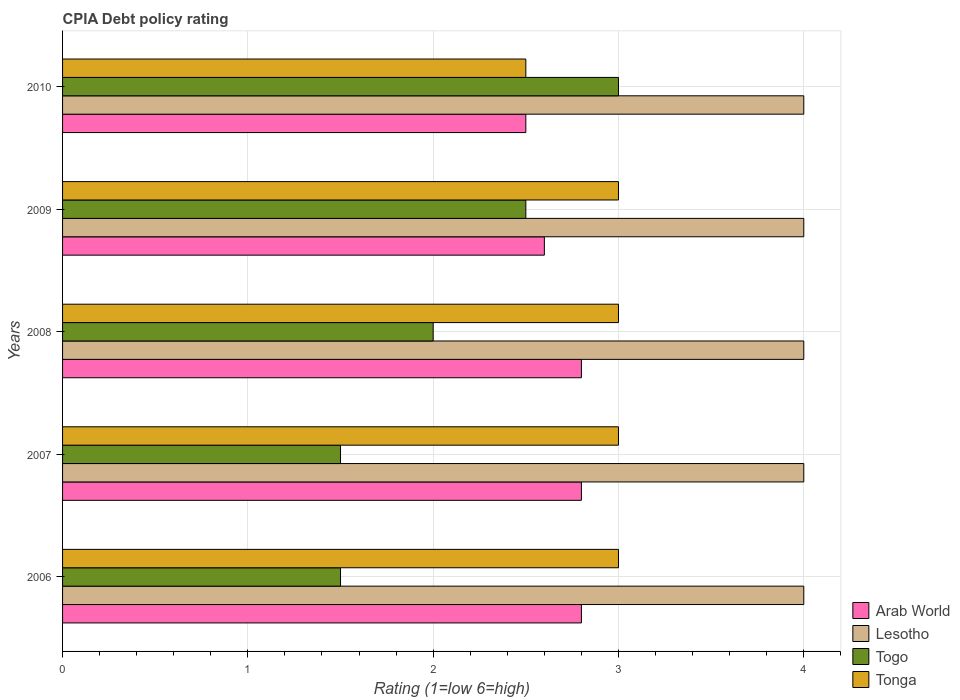How many groups of bars are there?
Offer a very short reply. 5. Are the number of bars per tick equal to the number of legend labels?
Your response must be concise. Yes. Are the number of bars on each tick of the Y-axis equal?
Provide a short and direct response. Yes. How many bars are there on the 5th tick from the top?
Provide a succinct answer. 4. How many bars are there on the 3rd tick from the bottom?
Your response must be concise. 4. What is the CPIA rating in Lesotho in 2009?
Your answer should be very brief. 4. Across all years, what is the maximum CPIA rating in Arab World?
Your answer should be very brief. 2.8. Across all years, what is the minimum CPIA rating in Tonga?
Ensure brevity in your answer.  2.5. What is the total CPIA rating in Tonga in the graph?
Your answer should be very brief. 14.5. What is the difference between the CPIA rating in Tonga in 2006 and the CPIA rating in Togo in 2010?
Make the answer very short. 0. In the year 2009, what is the difference between the CPIA rating in Lesotho and CPIA rating in Tonga?
Your answer should be very brief. 1. In how many years, is the CPIA rating in Lesotho greater than 2 ?
Offer a terse response. 5. What is the ratio of the CPIA rating in Togo in 2006 to that in 2010?
Your answer should be compact. 0.5. Is the CPIA rating in Lesotho in 2007 less than that in 2009?
Give a very brief answer. No. Is the difference between the CPIA rating in Lesotho in 2008 and 2010 greater than the difference between the CPIA rating in Tonga in 2008 and 2010?
Give a very brief answer. No. In how many years, is the CPIA rating in Lesotho greater than the average CPIA rating in Lesotho taken over all years?
Ensure brevity in your answer.  0. Is it the case that in every year, the sum of the CPIA rating in Arab World and CPIA rating in Togo is greater than the sum of CPIA rating in Lesotho and CPIA rating in Tonga?
Your answer should be compact. No. What does the 3rd bar from the top in 2007 represents?
Ensure brevity in your answer.  Lesotho. What does the 4th bar from the bottom in 2008 represents?
Your response must be concise. Tonga. Are the values on the major ticks of X-axis written in scientific E-notation?
Give a very brief answer. No. Does the graph contain any zero values?
Your response must be concise. No. What is the title of the graph?
Give a very brief answer. CPIA Debt policy rating. What is the label or title of the X-axis?
Give a very brief answer. Rating (1=low 6=high). What is the label or title of the Y-axis?
Ensure brevity in your answer.  Years. What is the Rating (1=low 6=high) in Arab World in 2006?
Your response must be concise. 2.8. What is the Rating (1=low 6=high) in Lesotho in 2006?
Your answer should be compact. 4. What is the Rating (1=low 6=high) of Tonga in 2006?
Your response must be concise. 3. What is the Rating (1=low 6=high) in Arab World in 2007?
Offer a terse response. 2.8. What is the Rating (1=low 6=high) of Togo in 2007?
Ensure brevity in your answer.  1.5. What is the Rating (1=low 6=high) of Arab World in 2008?
Offer a very short reply. 2.8. What is the Rating (1=low 6=high) in Togo in 2008?
Provide a short and direct response. 2. What is the Rating (1=low 6=high) of Tonga in 2008?
Make the answer very short. 3. What is the Rating (1=low 6=high) in Arab World in 2009?
Make the answer very short. 2.6. What is the Rating (1=low 6=high) in Lesotho in 2009?
Make the answer very short. 4. What is the Rating (1=low 6=high) of Togo in 2009?
Provide a succinct answer. 2.5. What is the Rating (1=low 6=high) of Lesotho in 2010?
Provide a short and direct response. 4. What is the Rating (1=low 6=high) of Tonga in 2010?
Offer a very short reply. 2.5. Across all years, what is the maximum Rating (1=low 6=high) in Arab World?
Your response must be concise. 2.8. Across all years, what is the maximum Rating (1=low 6=high) of Lesotho?
Your answer should be very brief. 4. Across all years, what is the maximum Rating (1=low 6=high) of Togo?
Make the answer very short. 3. Across all years, what is the minimum Rating (1=low 6=high) of Arab World?
Your answer should be compact. 2.5. What is the total Rating (1=low 6=high) of Arab World in the graph?
Keep it short and to the point. 13.5. What is the total Rating (1=low 6=high) in Togo in the graph?
Your response must be concise. 10.5. What is the total Rating (1=low 6=high) in Tonga in the graph?
Make the answer very short. 14.5. What is the difference between the Rating (1=low 6=high) of Togo in 2006 and that in 2007?
Your answer should be compact. 0. What is the difference between the Rating (1=low 6=high) in Tonga in 2006 and that in 2007?
Your answer should be compact. 0. What is the difference between the Rating (1=low 6=high) in Arab World in 2006 and that in 2008?
Offer a terse response. 0. What is the difference between the Rating (1=low 6=high) in Togo in 2006 and that in 2008?
Offer a very short reply. -0.5. What is the difference between the Rating (1=low 6=high) in Tonga in 2006 and that in 2008?
Provide a succinct answer. 0. What is the difference between the Rating (1=low 6=high) in Arab World in 2006 and that in 2009?
Offer a terse response. 0.2. What is the difference between the Rating (1=low 6=high) of Lesotho in 2006 and that in 2009?
Offer a very short reply. 0. What is the difference between the Rating (1=low 6=high) of Togo in 2006 and that in 2009?
Ensure brevity in your answer.  -1. What is the difference between the Rating (1=low 6=high) of Arab World in 2006 and that in 2010?
Give a very brief answer. 0.3. What is the difference between the Rating (1=low 6=high) of Lesotho in 2006 and that in 2010?
Make the answer very short. 0. What is the difference between the Rating (1=low 6=high) of Togo in 2006 and that in 2010?
Provide a short and direct response. -1.5. What is the difference between the Rating (1=low 6=high) of Tonga in 2006 and that in 2010?
Your answer should be very brief. 0.5. What is the difference between the Rating (1=low 6=high) of Togo in 2007 and that in 2008?
Offer a terse response. -0.5. What is the difference between the Rating (1=low 6=high) in Tonga in 2007 and that in 2008?
Give a very brief answer. 0. What is the difference between the Rating (1=low 6=high) of Lesotho in 2007 and that in 2009?
Keep it short and to the point. 0. What is the difference between the Rating (1=low 6=high) in Arab World in 2007 and that in 2010?
Offer a very short reply. 0.3. What is the difference between the Rating (1=low 6=high) of Lesotho in 2007 and that in 2010?
Your response must be concise. 0. What is the difference between the Rating (1=low 6=high) of Tonga in 2007 and that in 2010?
Make the answer very short. 0.5. What is the difference between the Rating (1=low 6=high) of Lesotho in 2008 and that in 2009?
Your answer should be very brief. 0. What is the difference between the Rating (1=low 6=high) in Togo in 2008 and that in 2009?
Ensure brevity in your answer.  -0.5. What is the difference between the Rating (1=low 6=high) in Tonga in 2008 and that in 2010?
Make the answer very short. 0.5. What is the difference between the Rating (1=low 6=high) of Lesotho in 2009 and that in 2010?
Your response must be concise. 0. What is the difference between the Rating (1=low 6=high) of Tonga in 2009 and that in 2010?
Provide a short and direct response. 0.5. What is the difference between the Rating (1=low 6=high) in Arab World in 2006 and the Rating (1=low 6=high) in Tonga in 2007?
Your response must be concise. -0.2. What is the difference between the Rating (1=low 6=high) of Lesotho in 2006 and the Rating (1=low 6=high) of Togo in 2007?
Provide a succinct answer. 2.5. What is the difference between the Rating (1=low 6=high) of Lesotho in 2006 and the Rating (1=low 6=high) of Tonga in 2007?
Make the answer very short. 1. What is the difference between the Rating (1=low 6=high) in Lesotho in 2006 and the Rating (1=low 6=high) in Togo in 2008?
Ensure brevity in your answer.  2. What is the difference between the Rating (1=low 6=high) in Lesotho in 2006 and the Rating (1=low 6=high) in Tonga in 2008?
Keep it short and to the point. 1. What is the difference between the Rating (1=low 6=high) of Togo in 2006 and the Rating (1=low 6=high) of Tonga in 2008?
Give a very brief answer. -1.5. What is the difference between the Rating (1=low 6=high) in Arab World in 2006 and the Rating (1=low 6=high) in Lesotho in 2009?
Make the answer very short. -1.2. What is the difference between the Rating (1=low 6=high) of Arab World in 2006 and the Rating (1=low 6=high) of Togo in 2009?
Make the answer very short. 0.3. What is the difference between the Rating (1=low 6=high) in Lesotho in 2006 and the Rating (1=low 6=high) in Tonga in 2009?
Keep it short and to the point. 1. What is the difference between the Rating (1=low 6=high) in Lesotho in 2006 and the Rating (1=low 6=high) in Togo in 2010?
Offer a very short reply. 1. What is the difference between the Rating (1=low 6=high) of Togo in 2006 and the Rating (1=low 6=high) of Tonga in 2010?
Give a very brief answer. -1. What is the difference between the Rating (1=low 6=high) in Arab World in 2007 and the Rating (1=low 6=high) in Lesotho in 2008?
Your answer should be compact. -1.2. What is the difference between the Rating (1=low 6=high) in Lesotho in 2007 and the Rating (1=low 6=high) in Togo in 2008?
Your response must be concise. 2. What is the difference between the Rating (1=low 6=high) of Lesotho in 2007 and the Rating (1=low 6=high) of Tonga in 2008?
Your answer should be very brief. 1. What is the difference between the Rating (1=low 6=high) of Arab World in 2007 and the Rating (1=low 6=high) of Togo in 2009?
Provide a succinct answer. 0.3. What is the difference between the Rating (1=low 6=high) in Arab World in 2007 and the Rating (1=low 6=high) in Tonga in 2009?
Ensure brevity in your answer.  -0.2. What is the difference between the Rating (1=low 6=high) in Togo in 2007 and the Rating (1=low 6=high) in Tonga in 2009?
Provide a short and direct response. -1.5. What is the difference between the Rating (1=low 6=high) in Arab World in 2007 and the Rating (1=low 6=high) in Lesotho in 2010?
Your response must be concise. -1.2. What is the difference between the Rating (1=low 6=high) in Arab World in 2007 and the Rating (1=low 6=high) in Togo in 2010?
Keep it short and to the point. -0.2. What is the difference between the Rating (1=low 6=high) of Arab World in 2007 and the Rating (1=low 6=high) of Tonga in 2010?
Your answer should be very brief. 0.3. What is the difference between the Rating (1=low 6=high) in Lesotho in 2007 and the Rating (1=low 6=high) in Togo in 2010?
Give a very brief answer. 1. What is the difference between the Rating (1=low 6=high) of Arab World in 2008 and the Rating (1=low 6=high) of Lesotho in 2009?
Your answer should be compact. -1.2. What is the difference between the Rating (1=low 6=high) of Arab World in 2008 and the Rating (1=low 6=high) of Togo in 2009?
Ensure brevity in your answer.  0.3. What is the difference between the Rating (1=low 6=high) of Lesotho in 2008 and the Rating (1=low 6=high) of Togo in 2009?
Provide a short and direct response. 1.5. What is the difference between the Rating (1=low 6=high) in Arab World in 2008 and the Rating (1=low 6=high) in Lesotho in 2010?
Your answer should be compact. -1.2. What is the difference between the Rating (1=low 6=high) in Arab World in 2008 and the Rating (1=low 6=high) in Togo in 2010?
Make the answer very short. -0.2. What is the difference between the Rating (1=low 6=high) in Lesotho in 2008 and the Rating (1=low 6=high) in Togo in 2010?
Make the answer very short. 1. What is the difference between the Rating (1=low 6=high) in Arab World in 2009 and the Rating (1=low 6=high) in Tonga in 2010?
Provide a succinct answer. 0.1. What is the difference between the Rating (1=low 6=high) in Lesotho in 2009 and the Rating (1=low 6=high) in Tonga in 2010?
Provide a succinct answer. 1.5. What is the average Rating (1=low 6=high) in Arab World per year?
Offer a very short reply. 2.7. What is the average Rating (1=low 6=high) of Lesotho per year?
Offer a very short reply. 4. What is the average Rating (1=low 6=high) of Togo per year?
Give a very brief answer. 2.1. In the year 2006, what is the difference between the Rating (1=low 6=high) in Arab World and Rating (1=low 6=high) in Togo?
Provide a short and direct response. 1.3. In the year 2006, what is the difference between the Rating (1=low 6=high) in Lesotho and Rating (1=low 6=high) in Tonga?
Make the answer very short. 1. In the year 2006, what is the difference between the Rating (1=low 6=high) in Togo and Rating (1=low 6=high) in Tonga?
Keep it short and to the point. -1.5. In the year 2007, what is the difference between the Rating (1=low 6=high) in Arab World and Rating (1=low 6=high) in Lesotho?
Your answer should be very brief. -1.2. In the year 2007, what is the difference between the Rating (1=low 6=high) of Arab World and Rating (1=low 6=high) of Togo?
Your answer should be very brief. 1.3. In the year 2007, what is the difference between the Rating (1=low 6=high) of Lesotho and Rating (1=low 6=high) of Togo?
Ensure brevity in your answer.  2.5. In the year 2007, what is the difference between the Rating (1=low 6=high) of Togo and Rating (1=low 6=high) of Tonga?
Provide a succinct answer. -1.5. In the year 2008, what is the difference between the Rating (1=low 6=high) of Arab World and Rating (1=low 6=high) of Togo?
Give a very brief answer. 0.8. In the year 2008, what is the difference between the Rating (1=low 6=high) in Arab World and Rating (1=low 6=high) in Tonga?
Offer a very short reply. -0.2. In the year 2008, what is the difference between the Rating (1=low 6=high) in Lesotho and Rating (1=low 6=high) in Togo?
Your response must be concise. 2. In the year 2008, what is the difference between the Rating (1=low 6=high) in Lesotho and Rating (1=low 6=high) in Tonga?
Offer a very short reply. 1. In the year 2009, what is the difference between the Rating (1=low 6=high) in Arab World and Rating (1=low 6=high) in Togo?
Your response must be concise. 0.1. In the year 2009, what is the difference between the Rating (1=low 6=high) in Arab World and Rating (1=low 6=high) in Tonga?
Offer a very short reply. -0.4. In the year 2009, what is the difference between the Rating (1=low 6=high) of Lesotho and Rating (1=low 6=high) of Togo?
Ensure brevity in your answer.  1.5. In the year 2009, what is the difference between the Rating (1=low 6=high) in Lesotho and Rating (1=low 6=high) in Tonga?
Keep it short and to the point. 1. In the year 2009, what is the difference between the Rating (1=low 6=high) in Togo and Rating (1=low 6=high) in Tonga?
Give a very brief answer. -0.5. In the year 2010, what is the difference between the Rating (1=low 6=high) in Arab World and Rating (1=low 6=high) in Togo?
Make the answer very short. -0.5. In the year 2010, what is the difference between the Rating (1=low 6=high) of Arab World and Rating (1=low 6=high) of Tonga?
Make the answer very short. 0. In the year 2010, what is the difference between the Rating (1=low 6=high) of Lesotho and Rating (1=low 6=high) of Togo?
Give a very brief answer. 1. In the year 2010, what is the difference between the Rating (1=low 6=high) of Togo and Rating (1=low 6=high) of Tonga?
Keep it short and to the point. 0.5. What is the ratio of the Rating (1=low 6=high) of Lesotho in 2006 to that in 2007?
Your answer should be compact. 1. What is the ratio of the Rating (1=low 6=high) in Tonga in 2006 to that in 2007?
Provide a succinct answer. 1. What is the ratio of the Rating (1=low 6=high) of Arab World in 2006 to that in 2008?
Keep it short and to the point. 1. What is the ratio of the Rating (1=low 6=high) of Tonga in 2006 to that in 2008?
Your answer should be compact. 1. What is the ratio of the Rating (1=low 6=high) of Arab World in 2006 to that in 2009?
Offer a terse response. 1.08. What is the ratio of the Rating (1=low 6=high) of Lesotho in 2006 to that in 2009?
Your answer should be very brief. 1. What is the ratio of the Rating (1=low 6=high) in Tonga in 2006 to that in 2009?
Your answer should be compact. 1. What is the ratio of the Rating (1=low 6=high) in Arab World in 2006 to that in 2010?
Your answer should be very brief. 1.12. What is the ratio of the Rating (1=low 6=high) in Togo in 2006 to that in 2010?
Offer a terse response. 0.5. What is the ratio of the Rating (1=low 6=high) in Tonga in 2006 to that in 2010?
Provide a short and direct response. 1.2. What is the ratio of the Rating (1=low 6=high) in Arab World in 2007 to that in 2008?
Make the answer very short. 1. What is the ratio of the Rating (1=low 6=high) in Lesotho in 2007 to that in 2008?
Give a very brief answer. 1. What is the ratio of the Rating (1=low 6=high) in Arab World in 2007 to that in 2009?
Offer a very short reply. 1.08. What is the ratio of the Rating (1=low 6=high) in Togo in 2007 to that in 2009?
Provide a short and direct response. 0.6. What is the ratio of the Rating (1=low 6=high) in Arab World in 2007 to that in 2010?
Offer a very short reply. 1.12. What is the ratio of the Rating (1=low 6=high) of Lesotho in 2007 to that in 2010?
Your answer should be compact. 1. What is the ratio of the Rating (1=low 6=high) in Arab World in 2008 to that in 2009?
Give a very brief answer. 1.08. What is the ratio of the Rating (1=low 6=high) in Arab World in 2008 to that in 2010?
Keep it short and to the point. 1.12. What is the ratio of the Rating (1=low 6=high) in Lesotho in 2008 to that in 2010?
Provide a succinct answer. 1. What is the ratio of the Rating (1=low 6=high) of Arab World in 2009 to that in 2010?
Your answer should be very brief. 1.04. What is the ratio of the Rating (1=low 6=high) in Togo in 2009 to that in 2010?
Ensure brevity in your answer.  0.83. What is the ratio of the Rating (1=low 6=high) of Tonga in 2009 to that in 2010?
Offer a very short reply. 1.2. What is the difference between the highest and the second highest Rating (1=low 6=high) in Arab World?
Ensure brevity in your answer.  0. What is the difference between the highest and the second highest Rating (1=low 6=high) in Togo?
Provide a short and direct response. 0.5. What is the difference between the highest and the second highest Rating (1=low 6=high) of Tonga?
Your answer should be compact. 0. What is the difference between the highest and the lowest Rating (1=low 6=high) in Arab World?
Keep it short and to the point. 0.3. 